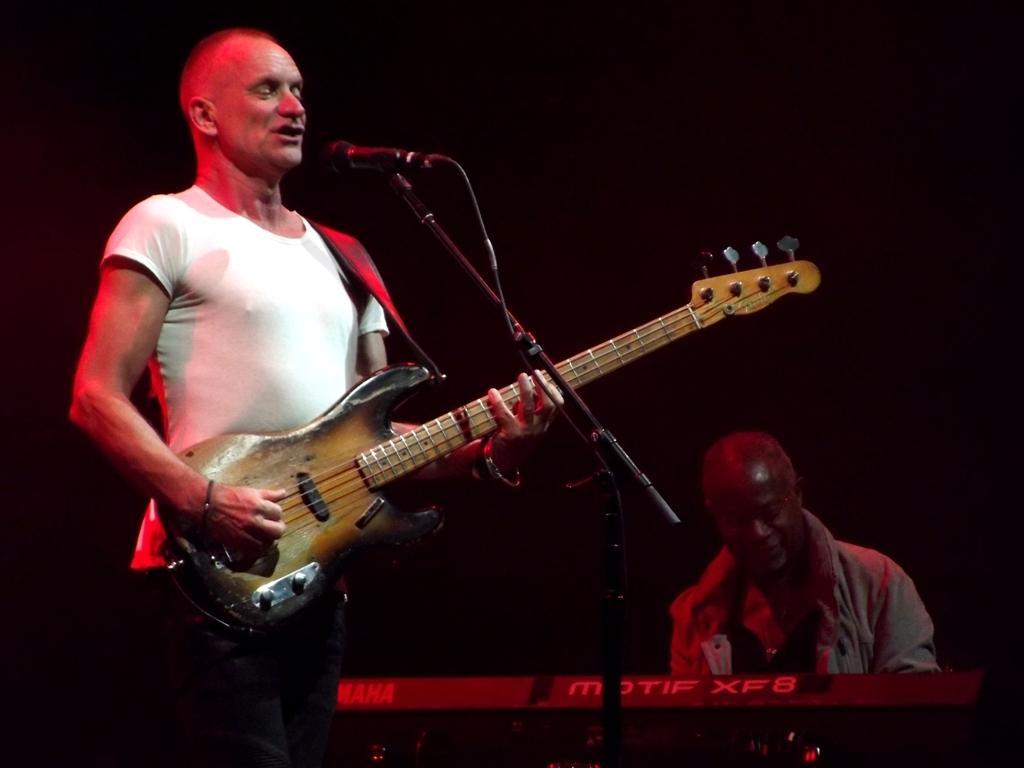How would you summarize this image in a sentence or two? In the image we can see two persons. The left man he is holding guitar and the right person is holding keyboard in front there is a microphone. 